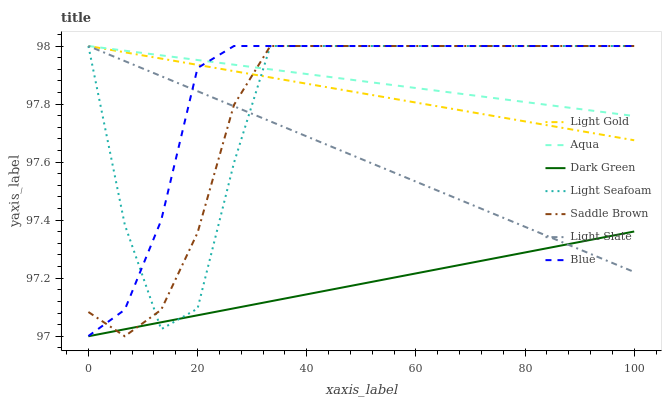Does Light Slate have the minimum area under the curve?
Answer yes or no. No. Does Light Slate have the maximum area under the curve?
Answer yes or no. No. Is Light Slate the smoothest?
Answer yes or no. No. Is Light Slate the roughest?
Answer yes or no. No. Does Light Slate have the lowest value?
Answer yes or no. No. Does Dark Green have the highest value?
Answer yes or no. No. Is Dark Green less than Aqua?
Answer yes or no. Yes. Is Light Gold greater than Dark Green?
Answer yes or no. Yes. Does Dark Green intersect Aqua?
Answer yes or no. No. 